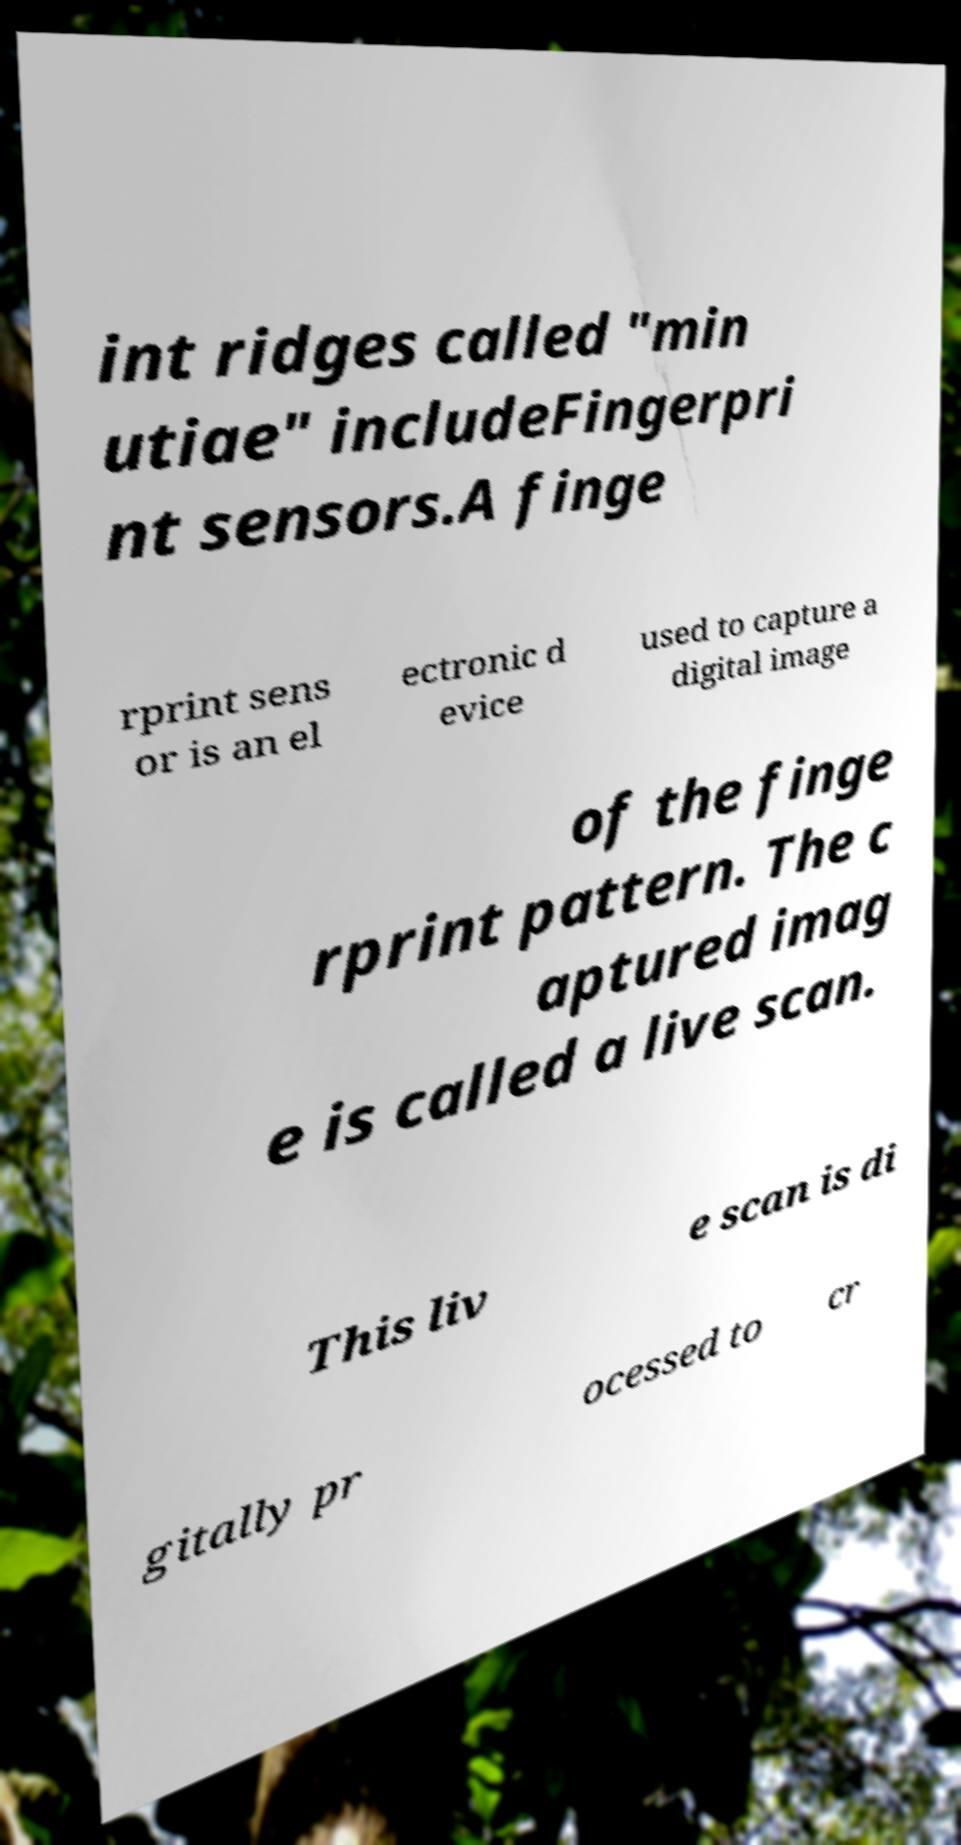Could you assist in decoding the text presented in this image and type it out clearly? int ridges called "min utiae" includeFingerpri nt sensors.A finge rprint sens or is an el ectronic d evice used to capture a digital image of the finge rprint pattern. The c aptured imag e is called a live scan. This liv e scan is di gitally pr ocessed to cr 